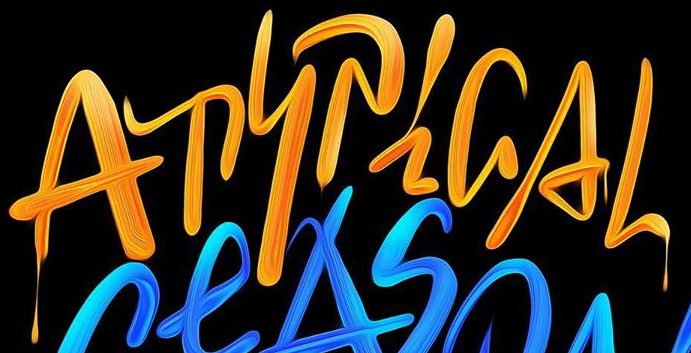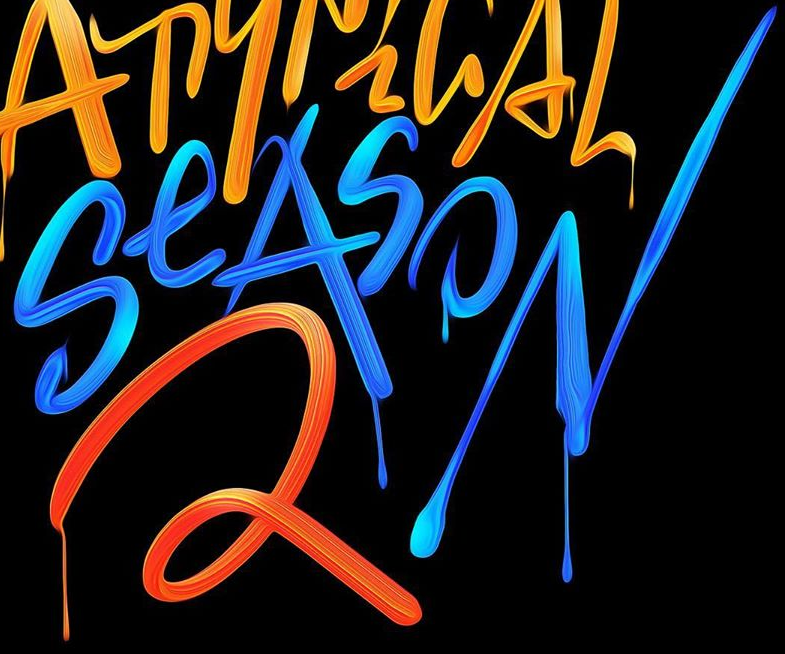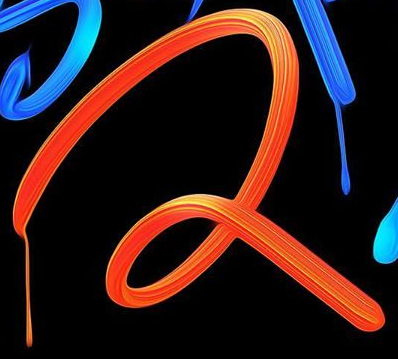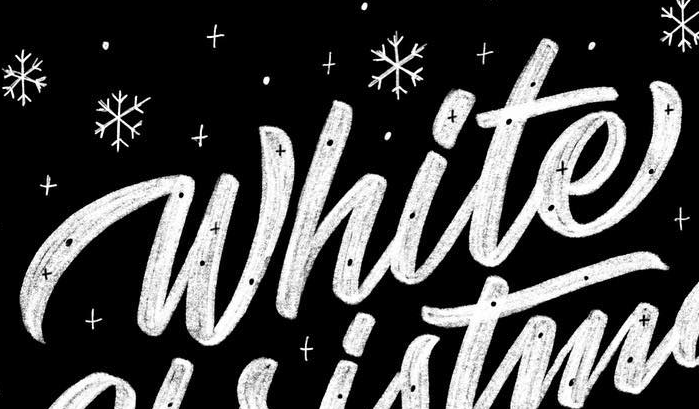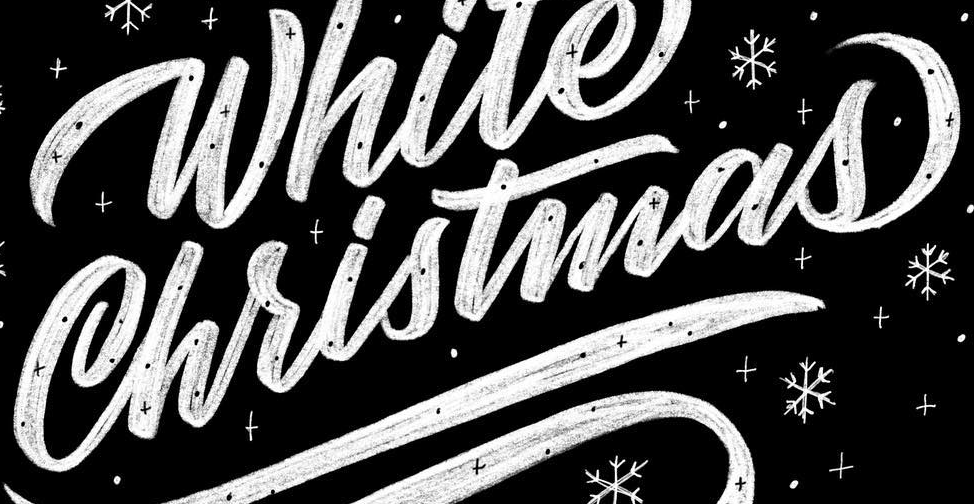What words are shown in these images in order, separated by a semicolon? ATYPiGAL; SeASON; 2; White; Christmas 